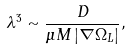Convert formula to latex. <formula><loc_0><loc_0><loc_500><loc_500>\lambda ^ { 3 } \sim \frac { D } { \mu M \left | \nabla \Omega _ { L } \right | } ,</formula> 